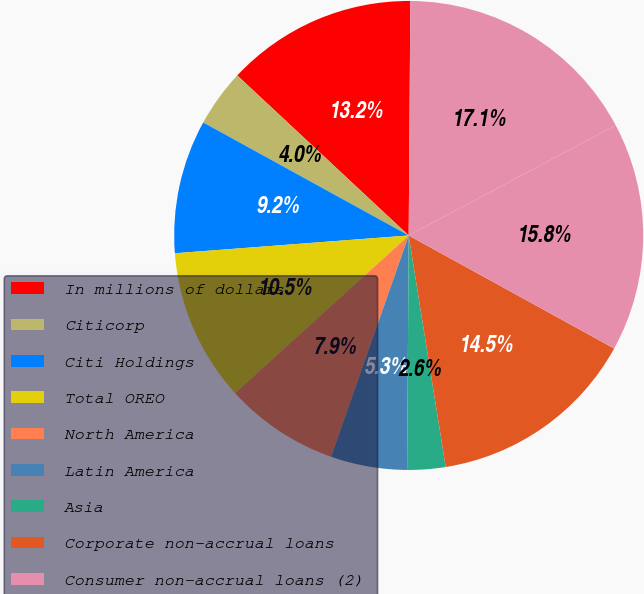Convert chart to OTSL. <chart><loc_0><loc_0><loc_500><loc_500><pie_chart><fcel>In millions of dollars<fcel>Citicorp<fcel>Citi Holdings<fcel>Total OREO<fcel>North America<fcel>Latin America<fcel>Asia<fcel>Corporate non-accrual loans<fcel>Consumer non-accrual loans (2)<fcel>Non-accrual loans (NAL)<nl><fcel>13.16%<fcel>3.95%<fcel>9.21%<fcel>10.53%<fcel>7.89%<fcel>5.26%<fcel>2.63%<fcel>14.47%<fcel>15.79%<fcel>17.1%<nl></chart> 